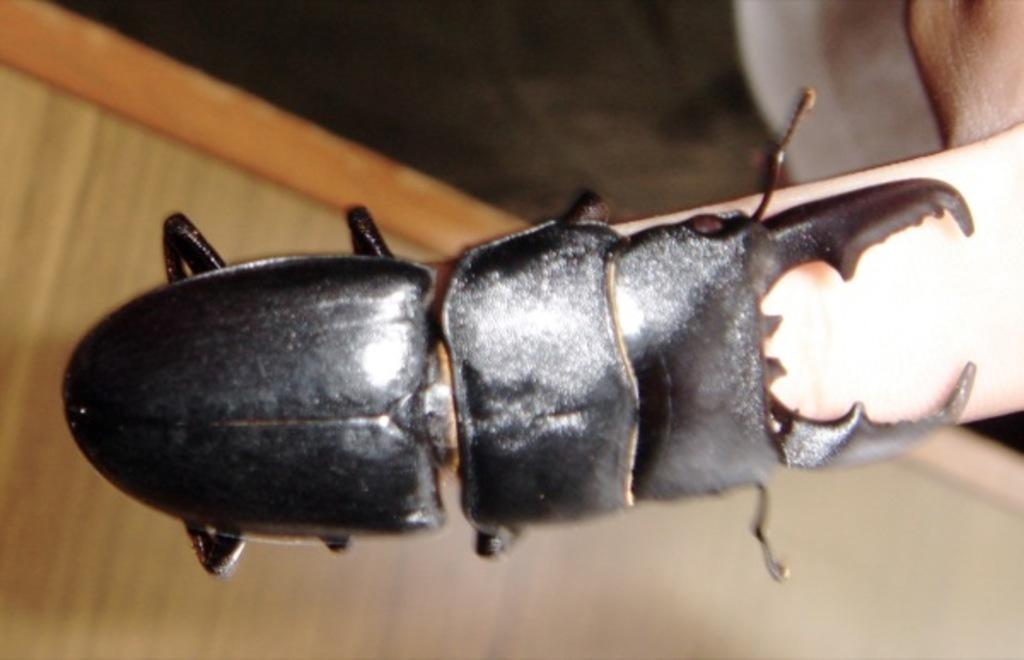What type of insect is in the image? There is a beetle in the image. Where is the beetle located? The beetle is on a finger. What can be seen at the bottom of the image? There is a wooden surface at the bottom of the image. What type of leaf is the boy holding in the image? There is no boy or leaf present in the image; it only features a beetle on a finger and a wooden surface. 